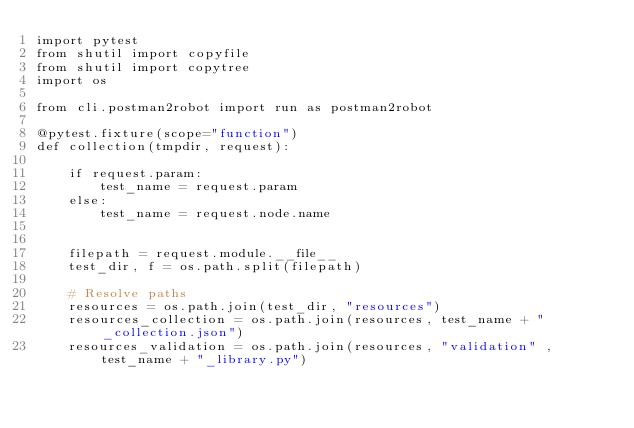Convert code to text. <code><loc_0><loc_0><loc_500><loc_500><_Python_>import pytest
from shutil import copyfile
from shutil import copytree
import os

from cli.postman2robot import run as postman2robot

@pytest.fixture(scope="function")
def collection(tmpdir, request):

    if request.param:
        test_name = request.param
    else:
        test_name = request.node.name


    filepath = request.module.__file__
    test_dir, f = os.path.split(filepath)

    # Resolve paths
    resources = os.path.join(test_dir, "resources")
    resources_collection = os.path.join(resources, test_name + "_collection.json")
    resources_validation = os.path.join(resources, "validation" , test_name + "_library.py")
</code> 